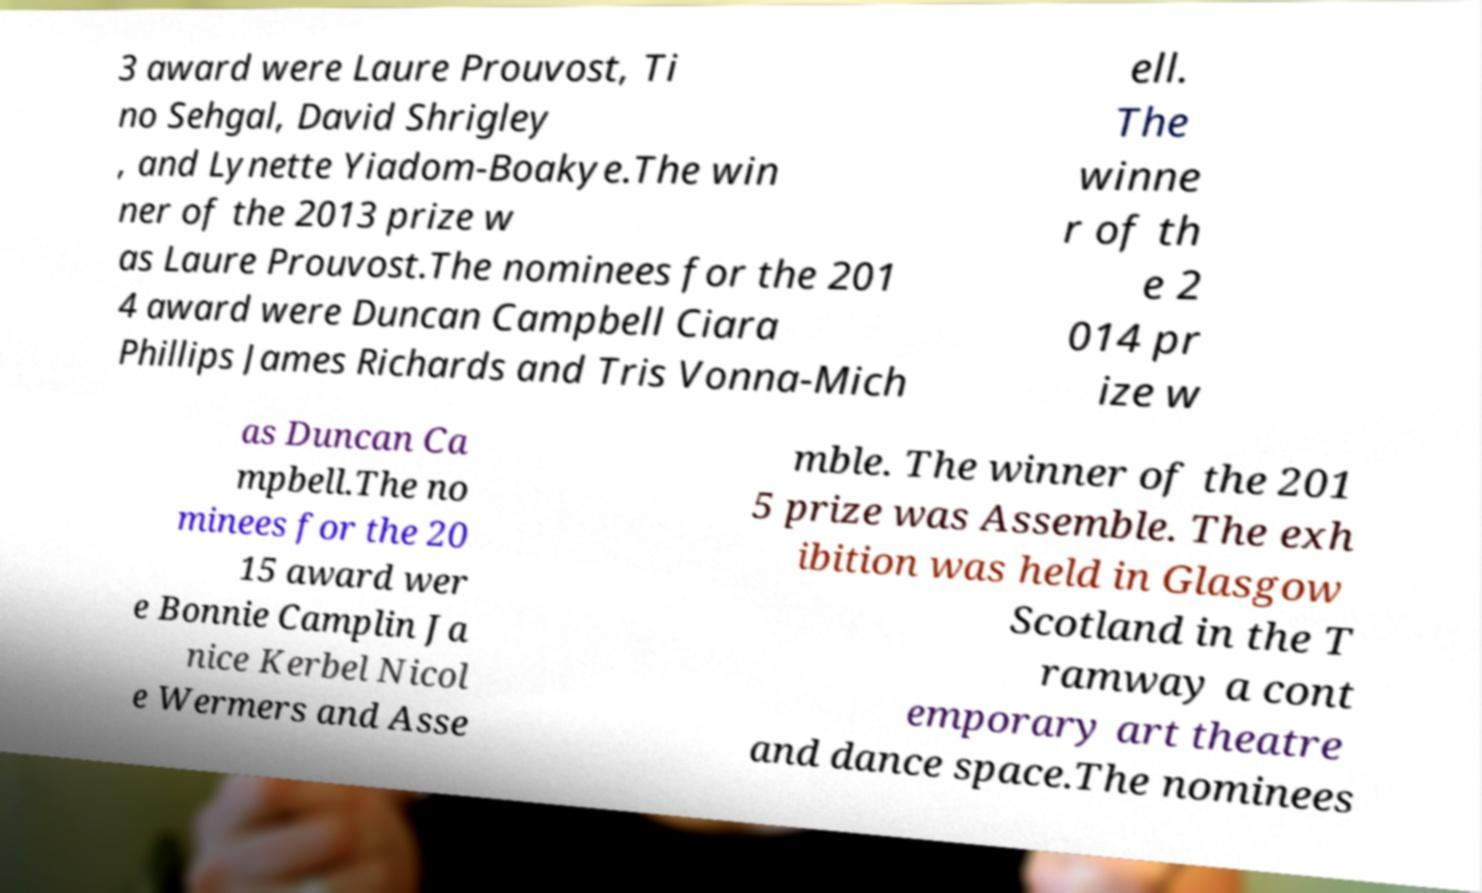Could you assist in decoding the text presented in this image and type it out clearly? 3 award were Laure Prouvost, Ti no Sehgal, David Shrigley , and Lynette Yiadom-Boakye.The win ner of the 2013 prize w as Laure Prouvost.The nominees for the 201 4 award were Duncan Campbell Ciara Phillips James Richards and Tris Vonna-Mich ell. The winne r of th e 2 014 pr ize w as Duncan Ca mpbell.The no minees for the 20 15 award wer e Bonnie Camplin Ja nice Kerbel Nicol e Wermers and Asse mble. The winner of the 201 5 prize was Assemble. The exh ibition was held in Glasgow Scotland in the T ramway a cont emporary art theatre and dance space.The nominees 